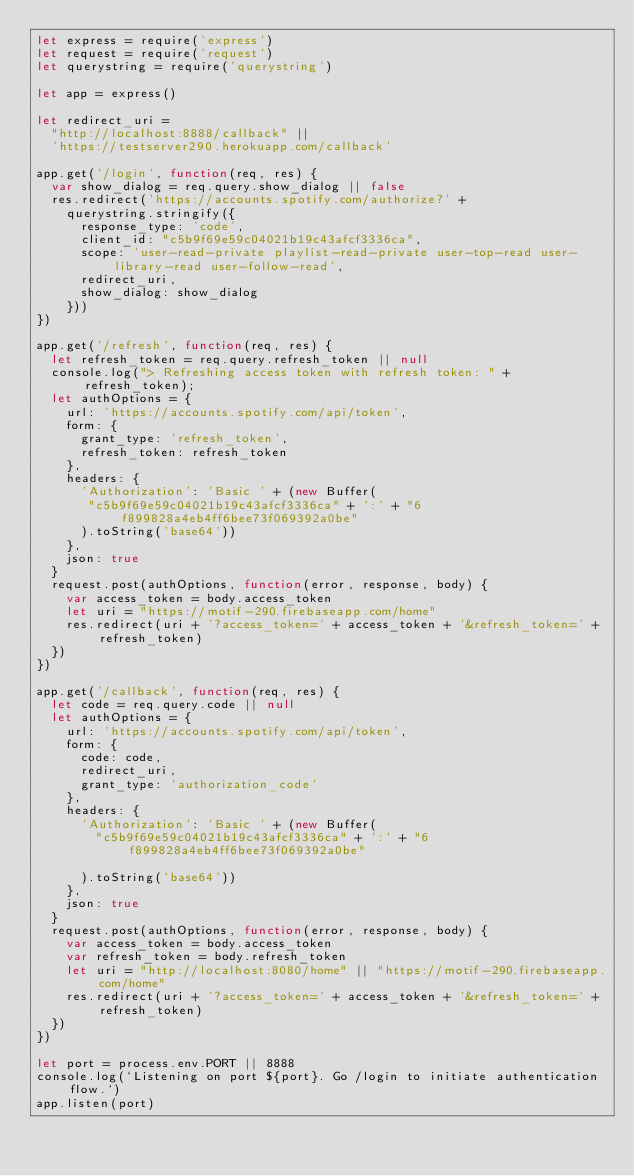Convert code to text. <code><loc_0><loc_0><loc_500><loc_500><_JavaScript_>let express = require('express')
let request = require('request')
let querystring = require('querystring')

let app = express()

let redirect_uri =
  "http://localhost:8888/callback" ||
  'https://testserver290.herokuapp.com/callback'

app.get('/login', function(req, res) {
  var show_dialog = req.query.show_dialog || false
  res.redirect('https://accounts.spotify.com/authorize?' +
    querystring.stringify({
      response_type: 'code',
      client_id: "c5b9f69e59c04021b19c43afcf3336ca",
      scope: 'user-read-private playlist-read-private user-top-read user-library-read user-follow-read',
      redirect_uri,
      show_dialog: show_dialog
    }))
})

app.get('/refresh', function(req, res) {
  let refresh_token = req.query.refresh_token || null
  console.log("> Refreshing access token with refresh token: " + refresh_token);
  let authOptions = {
    url: 'https://accounts.spotify.com/api/token',
    form: {
      grant_type: 'refresh_token',
      refresh_token: refresh_token
    },
    headers: {
      'Authorization': 'Basic ' + (new Buffer(
       "c5b9f69e59c04021b19c43afcf3336ca" + ':' + "6f899828a4eb4ff6bee73f069392a0be"
      ).toString('base64'))
    },
    json: true
  }
  request.post(authOptions, function(error, response, body) {
    var access_token = body.access_token
    let uri = "https://motif-290.firebaseapp.com/home"
    res.redirect(uri + '?access_token=' + access_token + '&refresh_token=' + refresh_token)
  })
})

app.get('/callback', function(req, res) {
  let code = req.query.code || null
  let authOptions = {
    url: 'https://accounts.spotify.com/api/token',
    form: {
      code: code,
      redirect_uri,
      grant_type: 'authorization_code'
    },
    headers: {
      'Authorization': 'Basic ' + (new Buffer(
        "c5b9f69e59c04021b19c43afcf3336ca" + ':' + "6f899828a4eb4ff6bee73f069392a0be"

      ).toString('base64'))
    },
    json: true
  }
  request.post(authOptions, function(error, response, body) {
    var access_token = body.access_token
    var refresh_token = body.refresh_token
    let uri = "http://localhost:8080/home" || "https://motif-290.firebaseapp.com/home"
    res.redirect(uri + '?access_token=' + access_token + '&refresh_token=' + refresh_token)
  })
})

let port = process.env.PORT || 8888
console.log(`Listening on port ${port}. Go /login to initiate authentication flow.`)
app.listen(port)</code> 